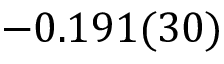<formula> <loc_0><loc_0><loc_500><loc_500>- 0 . 1 9 1 ( 3 0 )</formula> 